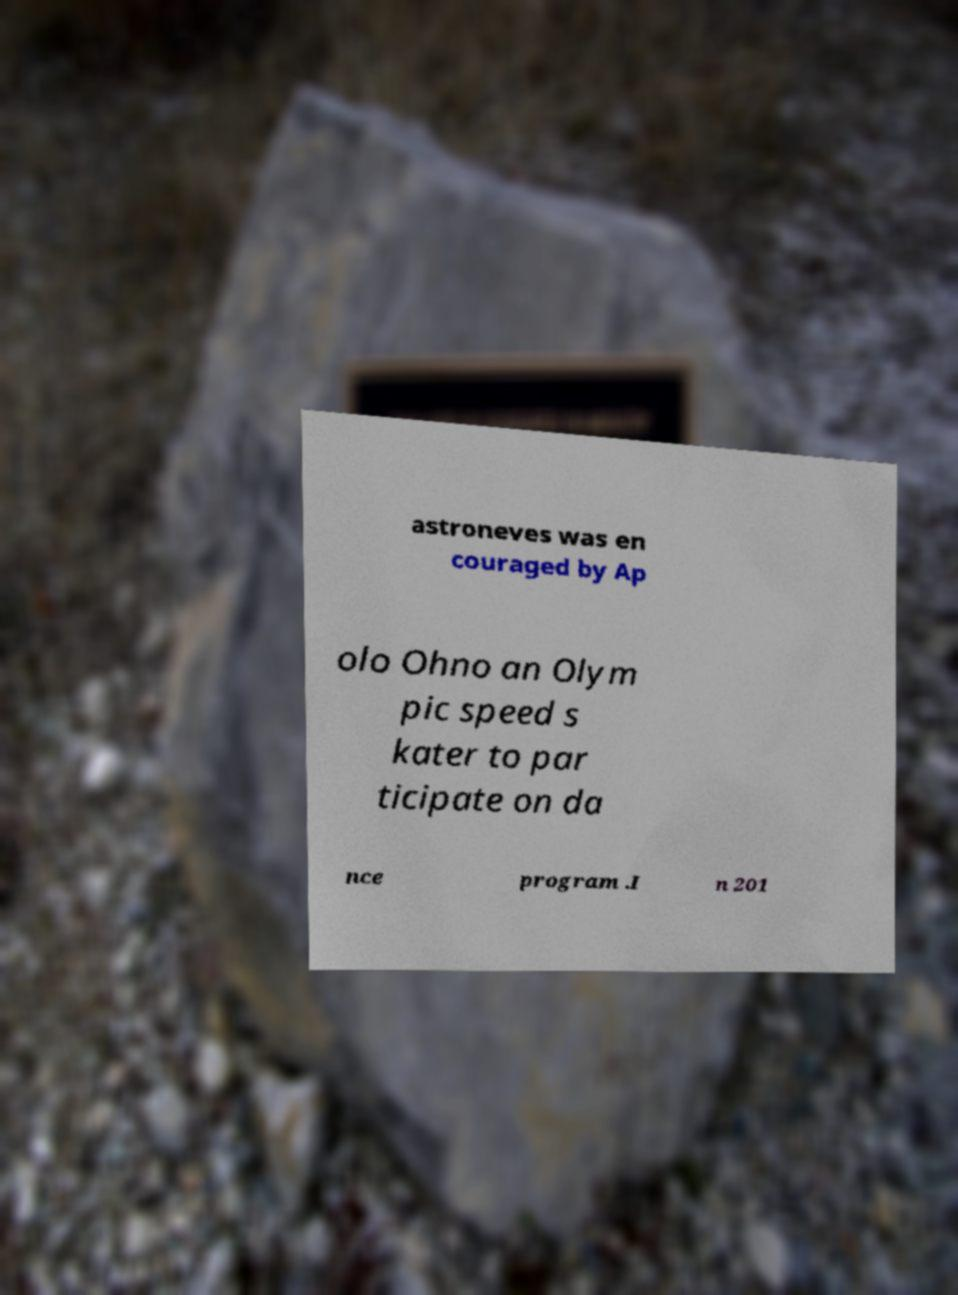I need the written content from this picture converted into text. Can you do that? astroneves was en couraged by Ap olo Ohno an Olym pic speed s kater to par ticipate on da nce program .I n 201 